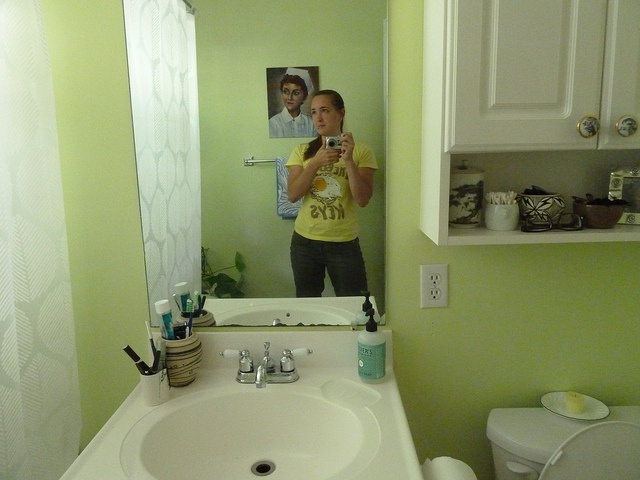Describe the objects in this image and their specific colors. I can see sink in beige, darkgray, and gray tones, people in beige, olive, black, and maroon tones, toilet in beige, gray, and darkgreen tones, people in beige, gray, and black tones, and bottle in beige, darkgreen, gray, black, and darkgray tones in this image. 